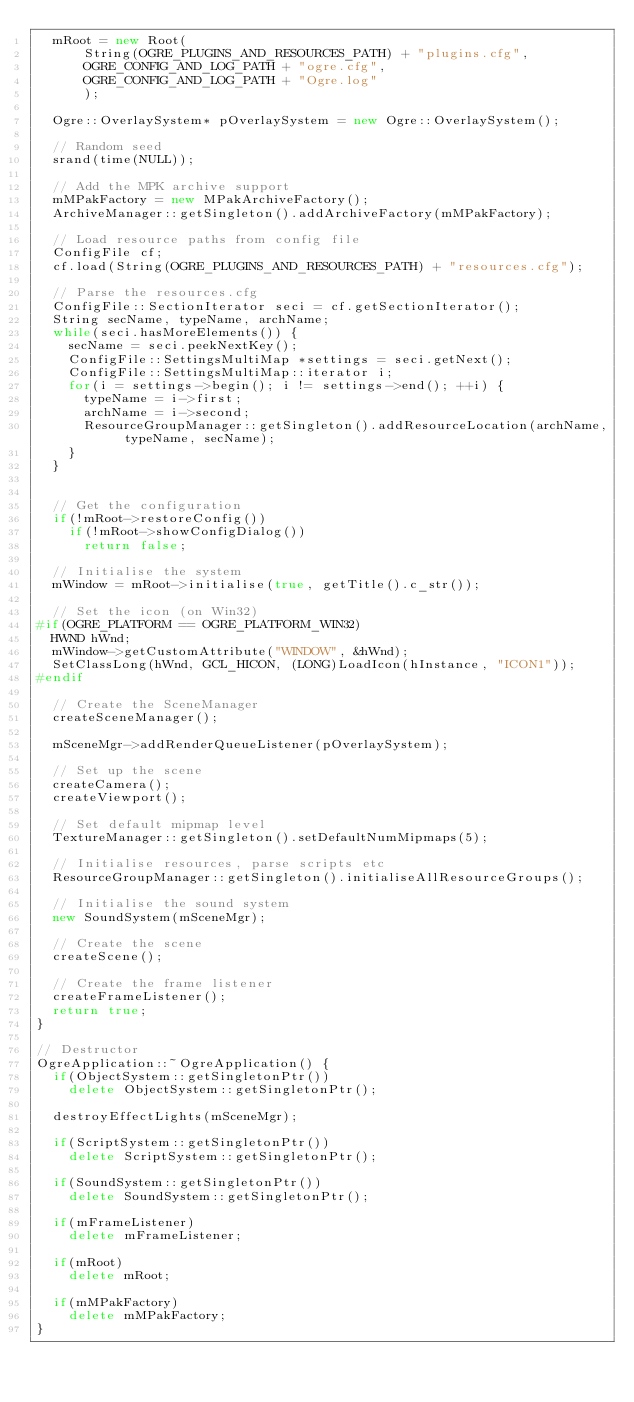Convert code to text. <code><loc_0><loc_0><loc_500><loc_500><_C++_>	mRoot = new Root(
			String(OGRE_PLUGINS_AND_RESOURCES_PATH) + "plugins.cfg",
			OGRE_CONFIG_AND_LOG_PATH + "ogre.cfg",
			OGRE_CONFIG_AND_LOG_PATH + "Ogre.log"
			);

	Ogre::OverlaySystem* pOverlaySystem = new Ogre::OverlaySystem();

	// Random seed
	srand(time(NULL));

	// Add the MPK archive support
	mMPakFactory = new MPakArchiveFactory();
	ArchiveManager::getSingleton().addArchiveFactory(mMPakFactory);

	// Load resource paths from config file
	ConfigFile cf;
	cf.load(String(OGRE_PLUGINS_AND_RESOURCES_PATH) + "resources.cfg");

	// Parse the resources.cfg
	ConfigFile::SectionIterator seci = cf.getSectionIterator();
	String secName, typeName, archName;
	while(seci.hasMoreElements()) {
		secName = seci.peekNextKey();
		ConfigFile::SettingsMultiMap *settings = seci.getNext();
		ConfigFile::SettingsMultiMap::iterator i;
		for(i = settings->begin(); i != settings->end(); ++i) {
			typeName = i->first;
			archName = i->second;
			ResourceGroupManager::getSingleton().addResourceLocation(archName, typeName, secName);
		}
	}


	// Get the configuration
	if(!mRoot->restoreConfig())
		if(!mRoot->showConfigDialog())
			return false;

	// Initialise the system
	mWindow = mRoot->initialise(true, getTitle().c_str());

	// Set the icon (on Win32)
#if(OGRE_PLATFORM == OGRE_PLATFORM_WIN32)
	HWND hWnd;
	mWindow->getCustomAttribute("WINDOW", &hWnd);
	SetClassLong(hWnd, GCL_HICON, (LONG)LoadIcon(hInstance, "ICON1"));
#endif

	// Create the SceneManager
	createSceneManager();

	mSceneMgr->addRenderQueueListener(pOverlaySystem);

	// Set up the scene
	createCamera();
	createViewport();

	// Set default mipmap level
	TextureManager::getSingleton().setDefaultNumMipmaps(5);

	// Initialise resources, parse scripts etc
	ResourceGroupManager::getSingleton().initialiseAllResourceGroups();

	// Initialise the sound system
	new SoundSystem(mSceneMgr);

	// Create the scene
	createScene();

	// Create the frame listener
	createFrameListener();
	return true;
}

// Destructor
OgreApplication::~OgreApplication() {
	if(ObjectSystem::getSingletonPtr())
		delete ObjectSystem::getSingletonPtr();

	destroyEffectLights(mSceneMgr);

	if(ScriptSystem::getSingletonPtr())
		delete ScriptSystem::getSingletonPtr();

	if(SoundSystem::getSingletonPtr())
		delete SoundSystem::getSingletonPtr();

	if(mFrameListener)
		delete mFrameListener;

	if(mRoot)
		delete mRoot;

	if(mMPakFactory)
		delete mMPakFactory;
}

</code> 